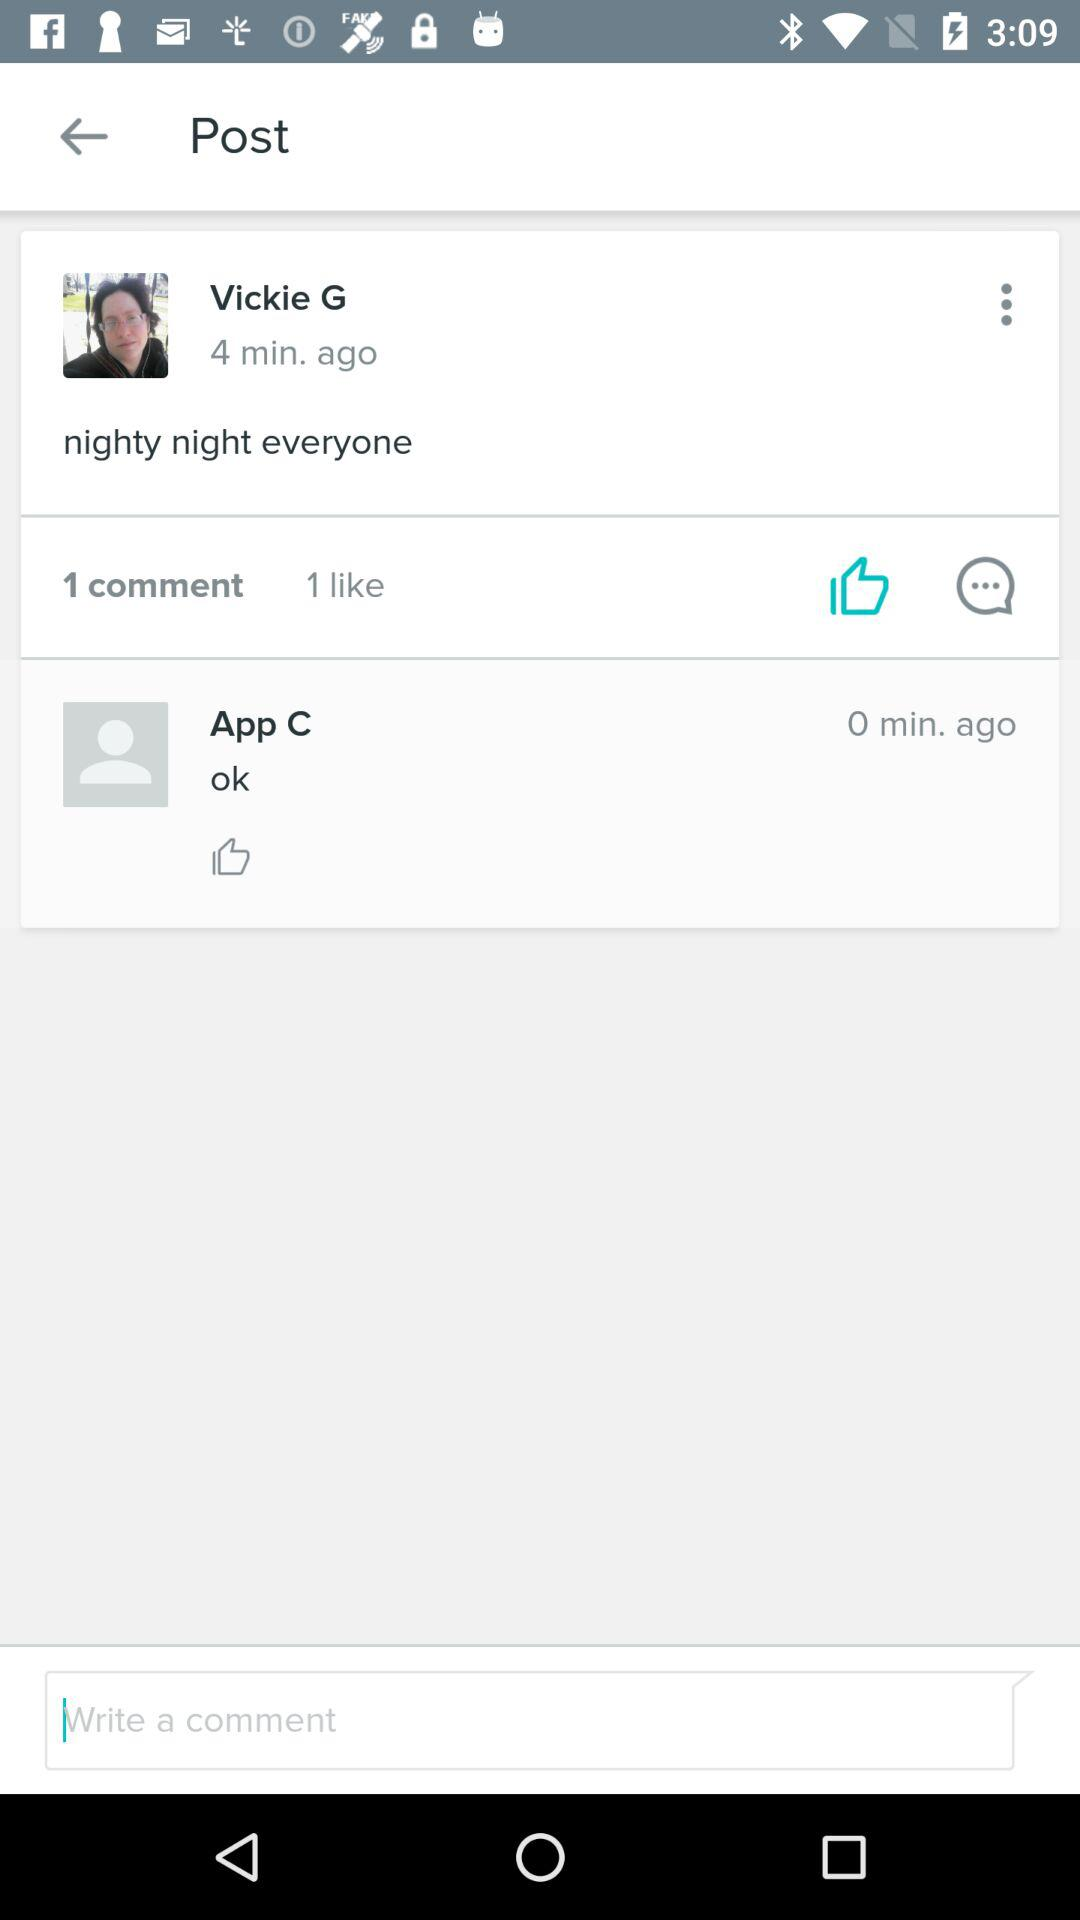How many comments are there on the post?
Answer the question using a single word or phrase. 1 